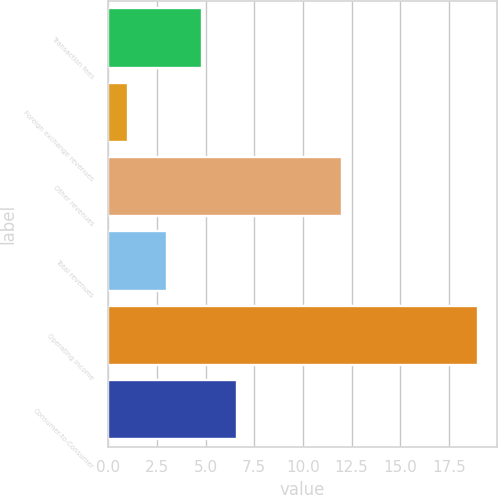Convert chart to OTSL. <chart><loc_0><loc_0><loc_500><loc_500><bar_chart><fcel>Transaction fees<fcel>Foreign exchange revenues<fcel>Other revenues<fcel>Total revenues<fcel>Operating income<fcel>Consumer-to-Consumer<nl><fcel>4.8<fcel>1<fcel>12<fcel>3<fcel>19<fcel>6.6<nl></chart> 